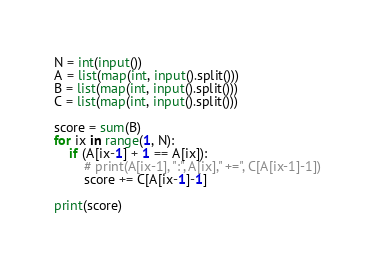Convert code to text. <code><loc_0><loc_0><loc_500><loc_500><_Python_>N = int(input())
A = list(map(int, input().split()))
B = list(map(int, input().split()))
C = list(map(int, input().split()))

score = sum(B)
for ix in range(1, N):
    if (A[ix-1] + 1 == A[ix]):
        # print(A[ix-1], ":", A[ix]," +=", C[A[ix-1]-1])
        score += C[A[ix-1]-1]

print(score)</code> 